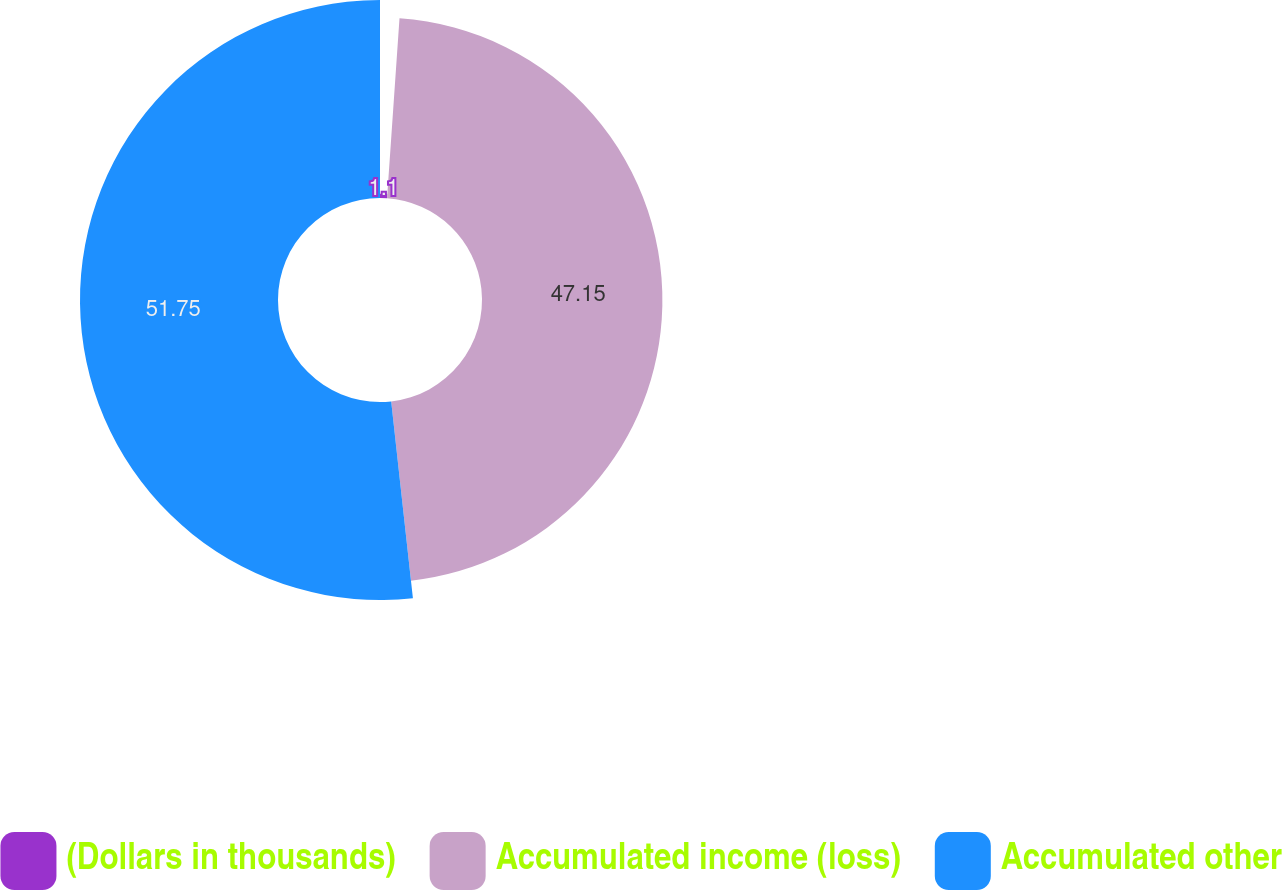Convert chart to OTSL. <chart><loc_0><loc_0><loc_500><loc_500><pie_chart><fcel>(Dollars in thousands)<fcel>Accumulated income (loss)<fcel>Accumulated other<nl><fcel>1.1%<fcel>47.15%<fcel>51.75%<nl></chart> 